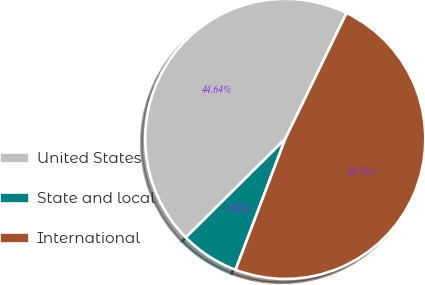Convert chart. <chart><loc_0><loc_0><loc_500><loc_500><pie_chart><fcel>United States<fcel>State and local<fcel>International<nl><fcel>44.64%<fcel>6.8%<fcel>48.56%<nl></chart> 